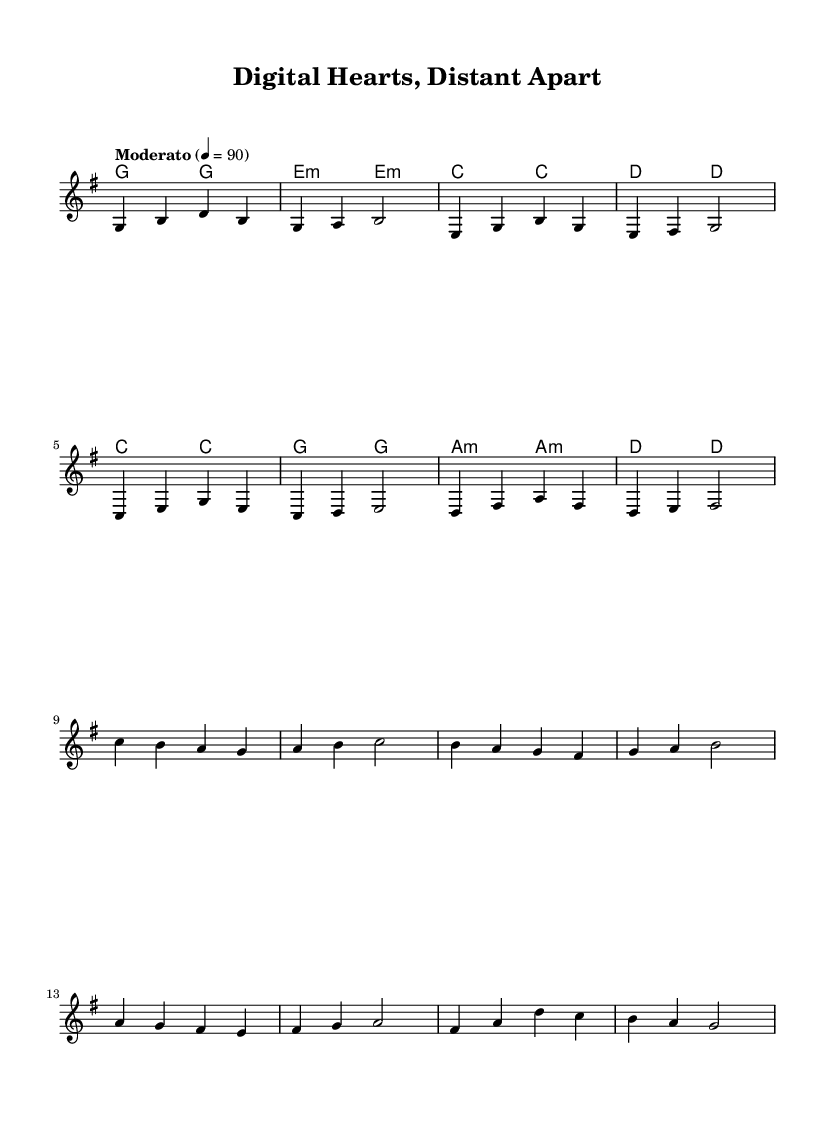What is the key signature of this music? The key signature indicates that the piece is in G major, which has one sharp (F#). This is identified at the beginning of the staff where the key signature is shown.
Answer: G major What is the time signature of this music? The time signature is located at the beginning of the score right after the clef. It is shown as 4/4, meaning there are four beats per measure and the quarter note gets one beat.
Answer: 4/4 What is the tempo marking of this music? The tempo marking appears just above the staff which states "Moderato" and indicates a specific metronome beat of 90. This suggests a moderate speed for the performance.
Answer: Moderato 4 = 90 How many measures are in the verse section? To determine the number of measures, you can count the bars in the verse section, which has a clear separation between measures. The verse contains eight measures.
Answer: 8 What is the main theme expressed in the lyrics of the chorus? The keywords in the chorus that signal the main theme include "love" and "distance." The lyrics focus on love that transcends physical separation, which is a common theme in long-distance relationships.
Answer: Love defies distance How many chords are being used in the verse? By analyzing the chord symbols above the staff during the verse, we can see that there are four different chord changes, indicating a change in harmonic support for the melody.
Answer: 4 Which musical section contains the line "Screens a -- glow in the night"? This line is part of the verse lyrics, as indicated by the placement of the words beneath the melody in the score layout. The structure of the song divides lyrics into verses and choruses, and this particular line is in the verse.
Answer: Verse 